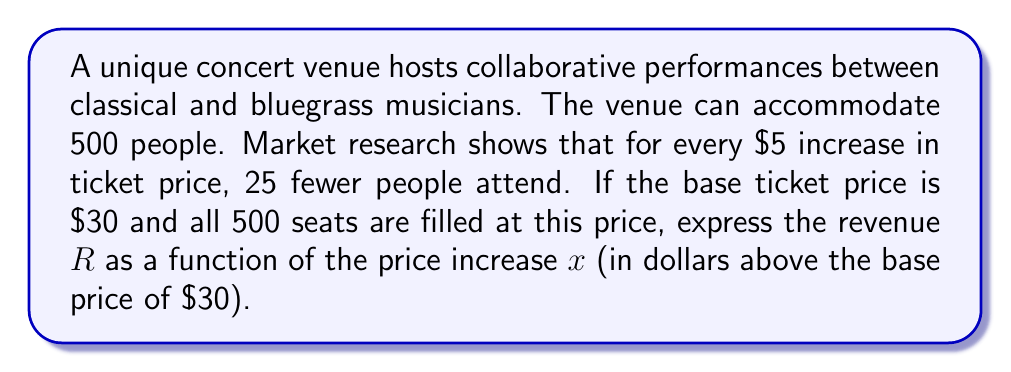Solve this math problem. Let's approach this step-by-step:

1) First, let's express the number of attendees as a function of $x$:
   At $x = 0$ (base price), there are 500 attendees.
   For every $5 increase, 25 fewer people attend.
   So, for $x$ dollars increase, $(25/5)x = 5x$ fewer people attend.
   Number of attendees: $N(x) = 500 - 5x$

2) Now, let's express the ticket price as a function of $x$:
   $P(x) = 30 + x$

3) Revenue is calculated by multiplying the number of attendees by the ticket price:
   $R(x) = N(x) \cdot P(x)$

4) Substituting our expressions:
   $R(x) = (500 - 5x)(30 + x)$

5) Expanding this expression:
   $R(x) = 15000 + 500x - 150x - 5x^2$
   $R(x) = 15000 + 350x - 5x^2$

6) Simplifying:
   $R(x) = -5x^2 + 350x + 15000$

This quadratic function represents the revenue as a function of the price increase $x$.
Answer: $R(x) = -5x^2 + 350x + 15000$ 